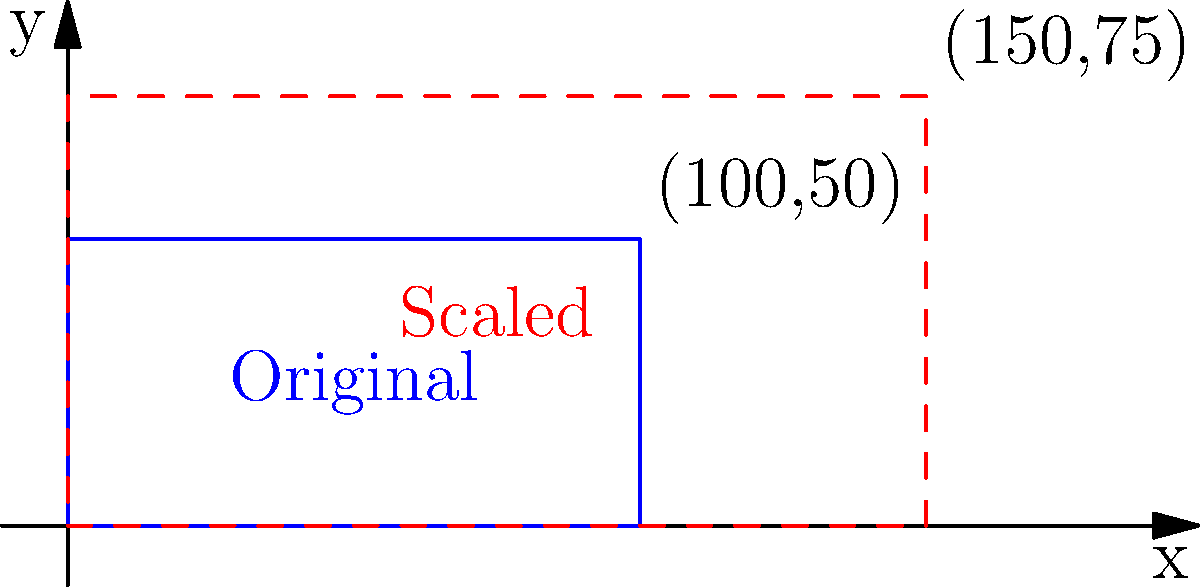A rectangular UI component has initial dimensions of 100x50 units in a coordinate system. You need to scale this component to a width of 150 units while maintaining its aspect ratio. What will be the new height of the component? To solve this problem, we'll follow these steps:

1. Identify the aspect ratio of the original component:
   Aspect ratio = width : height = 100 : 50 = 2 : 1

2. Calculate the scale factor:
   New width / Original width = 150 / 100 = 1.5

3. To maintain the aspect ratio, we need to apply the same scale factor to the height:
   New height = Original height * Scale factor
               = 50 * 1.5
               = 75 units

4. Verify the aspect ratio is maintained:
   New aspect ratio = 150 : 75 = 2 : 1

This confirms that the new dimensions (150x75) maintain the original aspect ratio of 2:1.

The problem can also be solved using the following proportion:
$$\frac{\text{Original width}}{\text{Original height}} = \frac{\text{New width}}{\text{New height}}$$

$$\frac{100}{50} = \frac{150}{x}$$

Cross-multiplying:
$$100x = 50 * 150$$
$$x = \frac{50 * 150}{100} = 75$$

This method arrives at the same result of 75 units for the new height.
Answer: 75 units 